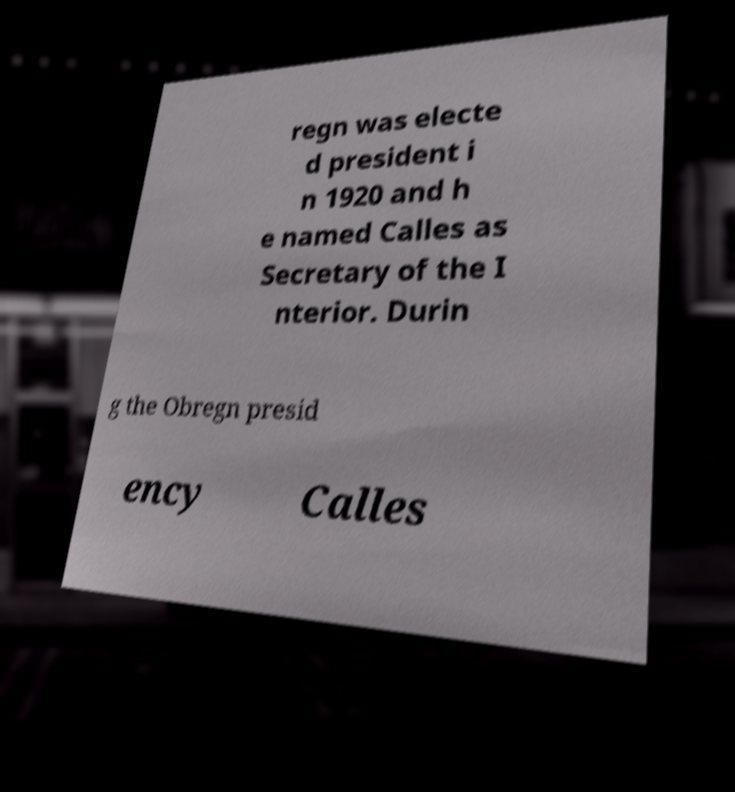Can you read and provide the text displayed in the image?This photo seems to have some interesting text. Can you extract and type it out for me? regn was electe d president i n 1920 and h e named Calles as Secretary of the I nterior. Durin g the Obregn presid ency Calles 